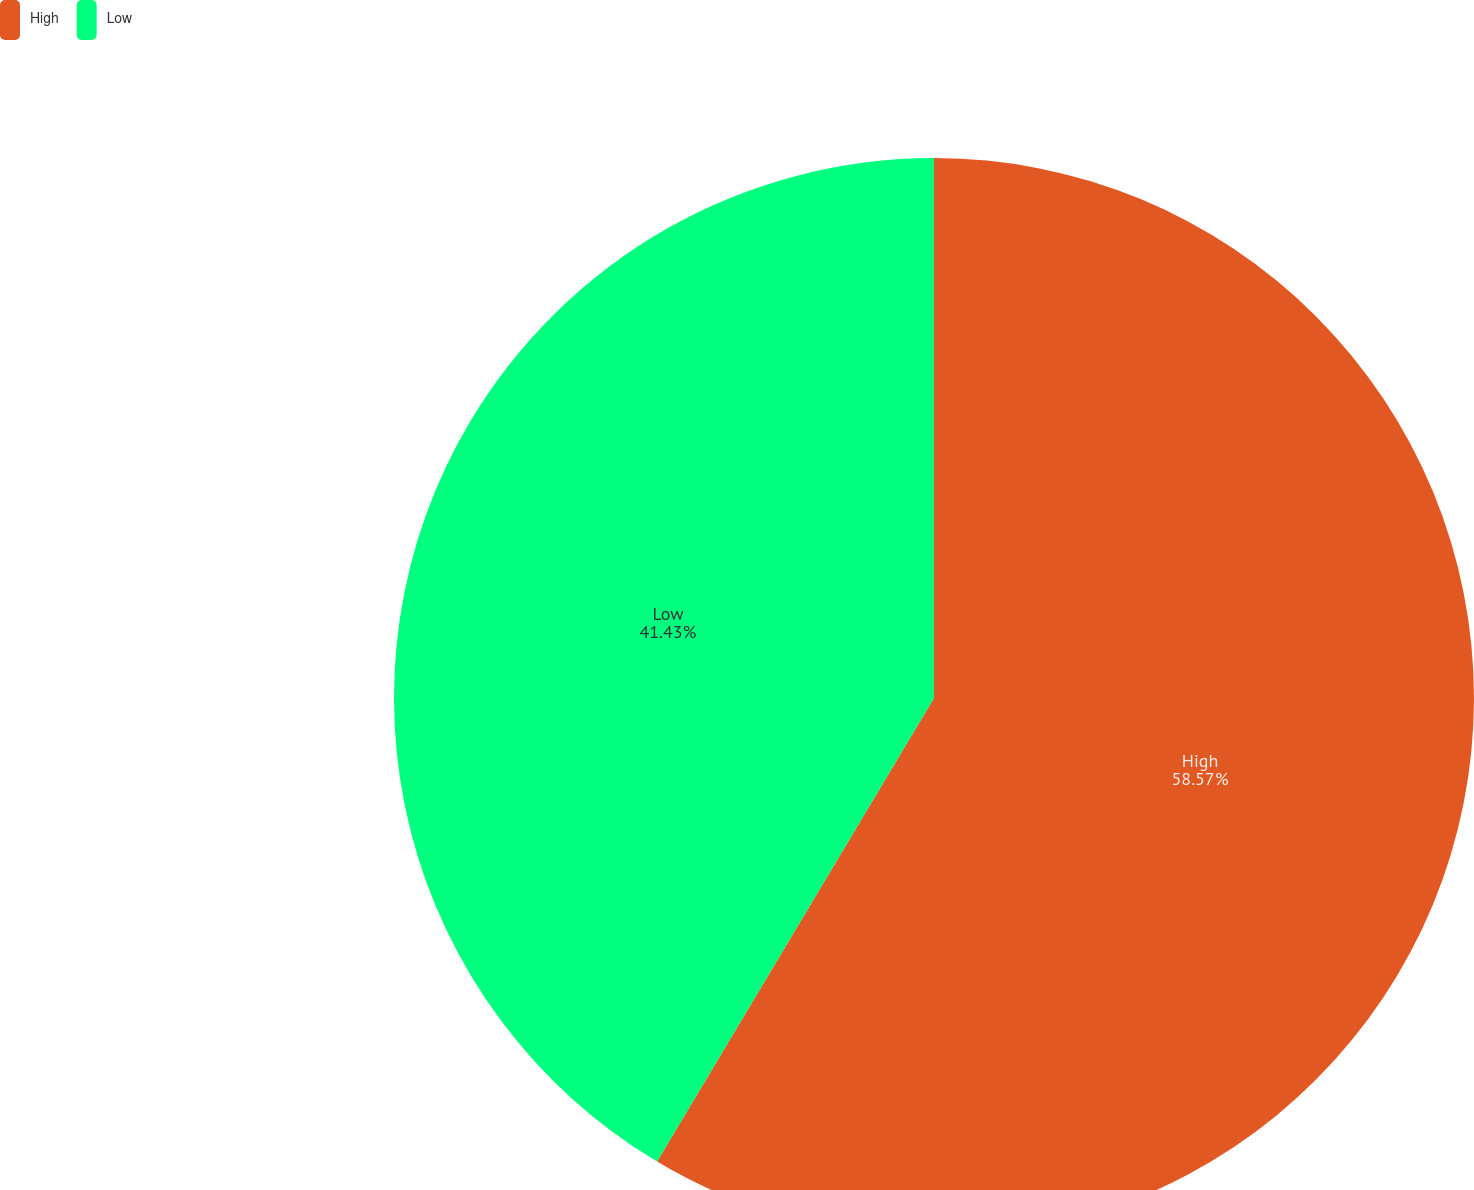Convert chart. <chart><loc_0><loc_0><loc_500><loc_500><pie_chart><fcel>High<fcel>Low<nl><fcel>58.57%<fcel>41.43%<nl></chart> 